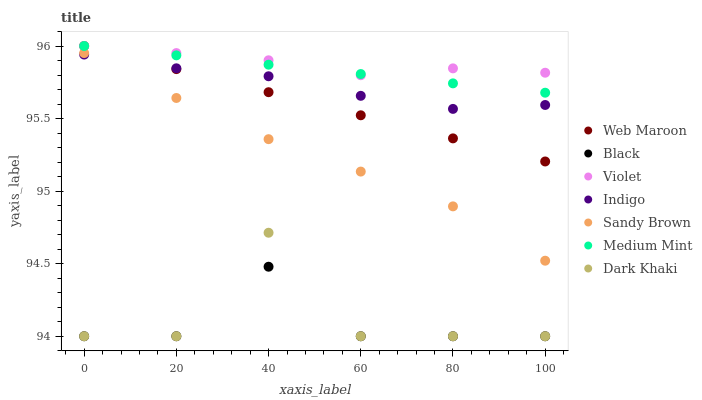Does Black have the minimum area under the curve?
Answer yes or no. Yes. Does Violet have the maximum area under the curve?
Answer yes or no. Yes. Does Indigo have the minimum area under the curve?
Answer yes or no. No. Does Indigo have the maximum area under the curve?
Answer yes or no. No. Is Medium Mint the smoothest?
Answer yes or no. Yes. Is Dark Khaki the roughest?
Answer yes or no. Yes. Is Indigo the smoothest?
Answer yes or no. No. Is Indigo the roughest?
Answer yes or no. No. Does Dark Khaki have the lowest value?
Answer yes or no. Yes. Does Indigo have the lowest value?
Answer yes or no. No. Does Violet have the highest value?
Answer yes or no. Yes. Does Indigo have the highest value?
Answer yes or no. No. Is Sandy Brown less than Medium Mint?
Answer yes or no. Yes. Is Sandy Brown greater than Dark Khaki?
Answer yes or no. Yes. Does Black intersect Dark Khaki?
Answer yes or no. Yes. Is Black less than Dark Khaki?
Answer yes or no. No. Is Black greater than Dark Khaki?
Answer yes or no. No. Does Sandy Brown intersect Medium Mint?
Answer yes or no. No. 